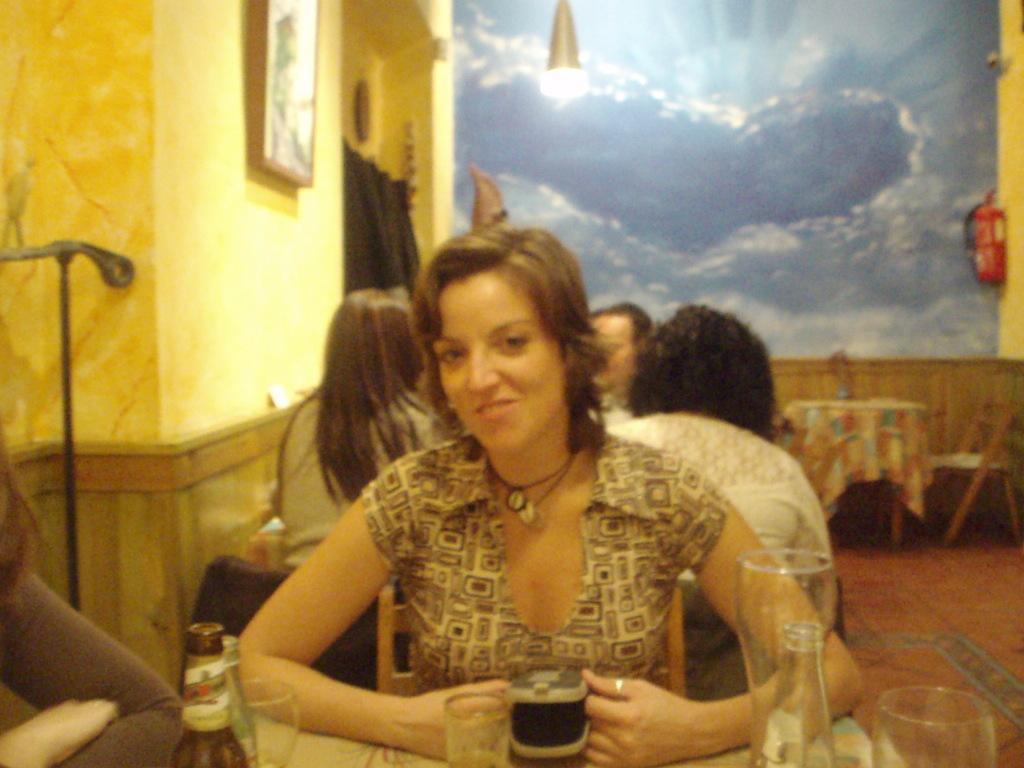Describe this image in one or two sentences. In this image there is a woman sitting in chair and in table there are bottle, glass, pouch, and in back ground there are group of persons sitting , wall poster, light, curtain, oxygen cylinder. 